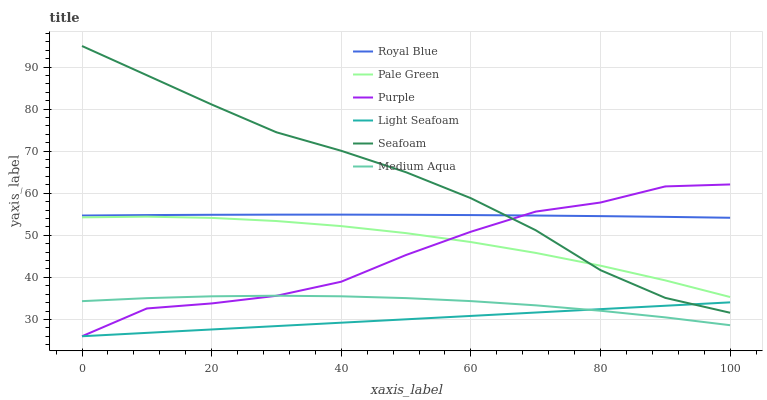Does Light Seafoam have the minimum area under the curve?
Answer yes or no. Yes. Does Seafoam have the maximum area under the curve?
Answer yes or no. Yes. Does Royal Blue have the minimum area under the curve?
Answer yes or no. No. Does Royal Blue have the maximum area under the curve?
Answer yes or no. No. Is Light Seafoam the smoothest?
Answer yes or no. Yes. Is Purple the roughest?
Answer yes or no. Yes. Is Seafoam the smoothest?
Answer yes or no. No. Is Seafoam the roughest?
Answer yes or no. No. Does Purple have the lowest value?
Answer yes or no. Yes. Does Seafoam have the lowest value?
Answer yes or no. No. Does Seafoam have the highest value?
Answer yes or no. Yes. Does Royal Blue have the highest value?
Answer yes or no. No. Is Light Seafoam less than Royal Blue?
Answer yes or no. Yes. Is Royal Blue greater than Pale Green?
Answer yes or no. Yes. Does Light Seafoam intersect Seafoam?
Answer yes or no. Yes. Is Light Seafoam less than Seafoam?
Answer yes or no. No. Is Light Seafoam greater than Seafoam?
Answer yes or no. No. Does Light Seafoam intersect Royal Blue?
Answer yes or no. No. 